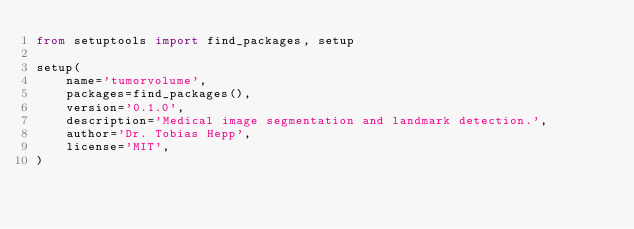<code> <loc_0><loc_0><loc_500><loc_500><_Python_>from setuptools import find_packages, setup

setup(
    name='tumorvolume',
    packages=find_packages(),
    version='0.1.0',
    description='Medical image segmentation and landmark detection.',
    author='Dr. Tobias Hepp',
    license='MIT',
)
</code> 